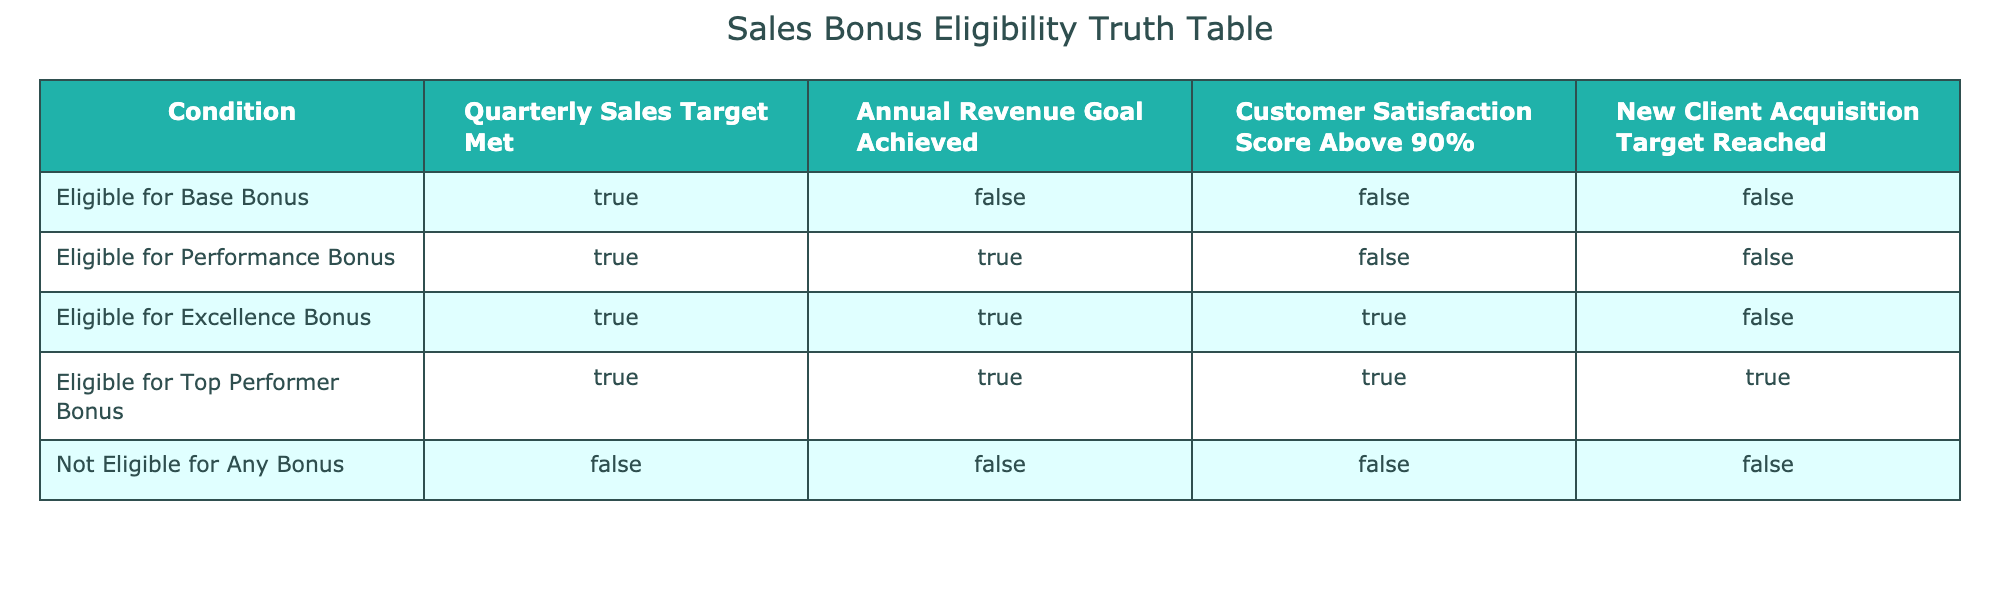What are the criteria for being eligible for a Base Bonus? The criteria for being eligible for a Base Bonus according to the table are meeting the Quarterly Sales Target, while the other conditions are not relevant. Specifically, the Quarterly Sales Target must be True, while the Annual Revenue Goal Achieved, Customer Satisfaction Score, and New Client Acquisition Target must all be False.
Answer: Quarterly Sales Target Met: True, Annual Revenue Goal Achieved: False, Customer Satisfaction Score Above 90%: False, New Client Acquisition Target Reached: False Is a sales executive who meets the Quarterly Sales Target and Annual Revenue Goal but does not meet the Customer Satisfaction Score eligible for a bonus? According to the table, if a sales executive meets the Quarterly Sales Target and Annual Revenue Goal but fails to exceed the Customer Satisfaction Score of 90%, they would be eligible for a Performance Bonus since they meet the criteria for that particular bonus.
Answer: Yes, they are eligible for a Performance Bonus What is the relationship between Customer Satisfaction Score and eligibility for bonuses? Reviewing the table indicates that only those who meet the Customer Satisfaction Score requirement of above 90% can be eligible for either the Excellence Bonus or the Top Performer Bonus. Therefore, customer satisfaction is crucial for higher-level bonuses.
Answer: Customer satisfaction is essential for Excellence and Top Performer bonuses What is the maximum number of bonuses a sales executive can be eligible for based on the conditions provided? To determine the maximum number of bonuses, we see that a sales executive can meet all four conditions to be eligible for the Top Performer Bonus if all conditions are true. The hierarchy shows that the Top Performer Bonus is the most beneficial, so they can be eligible for just one bonus at a time, which is the highest one they qualify for.
Answer: One bonus maximum If an employee does not meet any of the criteria, what is their bonus eligibility status? The table states that if none of the criteria is met, then the employee falls under the category "Not Eligible for Any Bonus," indicating they cannot receive any bonuses at all.
Answer: Not Eligible for Any Bonus What would happen if an employee meets all criteria except for the New Client Acquisition Target? The table shows that meeting all criteria except the New Client Acquisition Target would not allow the employee to qualify for the Top Performer Bonus. They could still qualify for the Excellence Bonus if both the Quarterly Sales Target and the Annual Revenue Goal are met along with the Customer Satisfaction Score.
Answer: Eligible for the Excellence Bonus How many conditions must be met to qualify for the Excellence Bonus? To qualify for the Excellence Bonus, the employee must meet three specific conditions: the Quarterly Sales Target, the Annual Revenue Goal, and the Customer Satisfaction Score, while New Client Acquisition does not need to be fulfilled.
Answer: Three conditions must be met Is there any condition under which one could be eligible for both the Excellence Bonus and Top Performer Bonus? No, according to the table, to be eligible for the Top Performer Bonus, all conditions must be met, including New Client Acquisition Target Reached, which is not required for the Excellence Bonus. This creates a scenario where achieving both is impossible due to conflicting requirements.
Answer: No, it's not possible to be eligible for both 